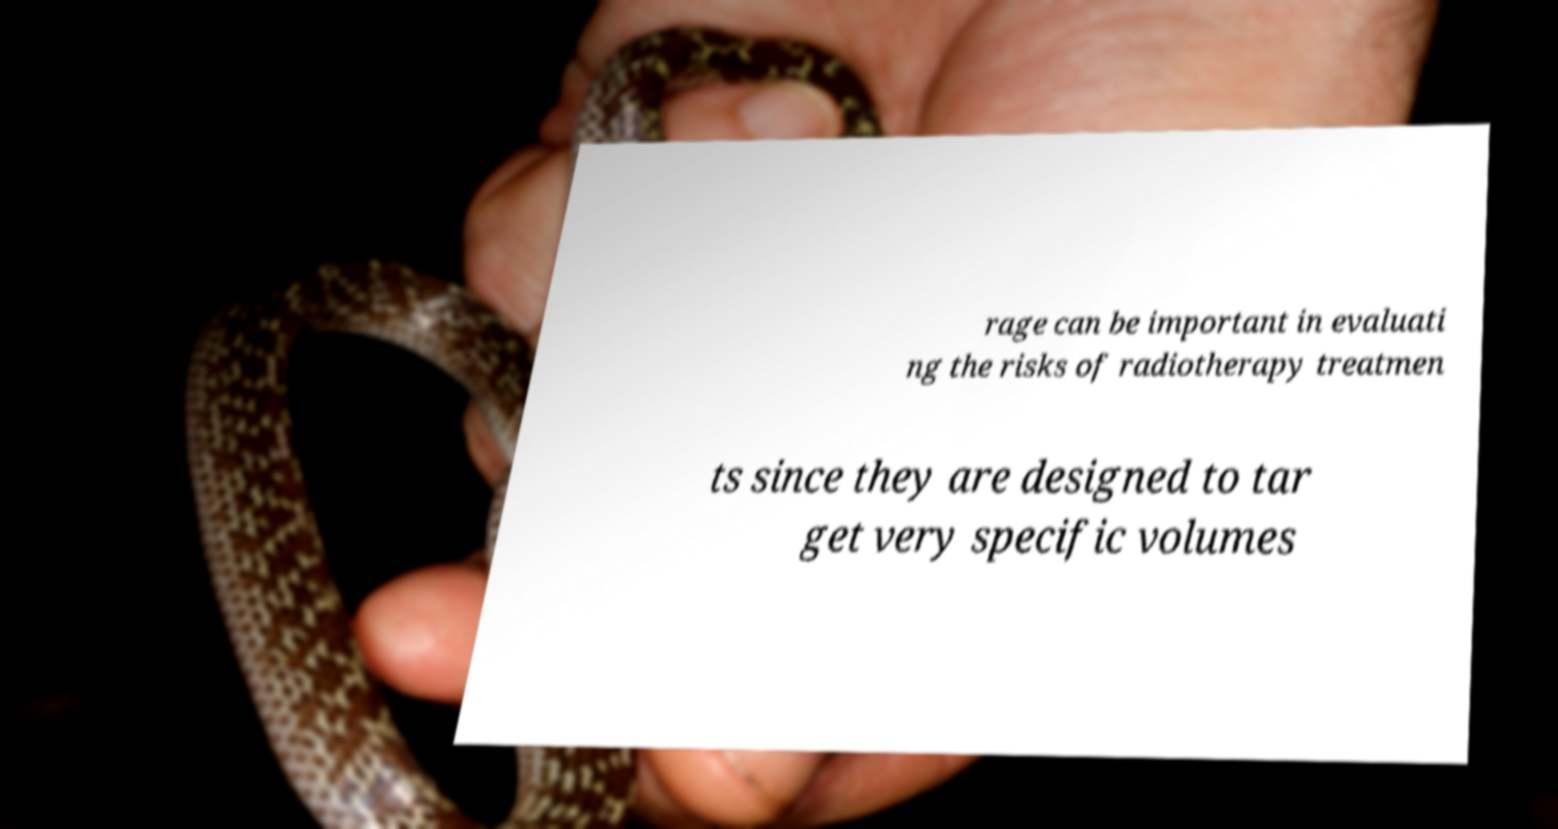There's text embedded in this image that I need extracted. Can you transcribe it verbatim? rage can be important in evaluati ng the risks of radiotherapy treatmen ts since they are designed to tar get very specific volumes 